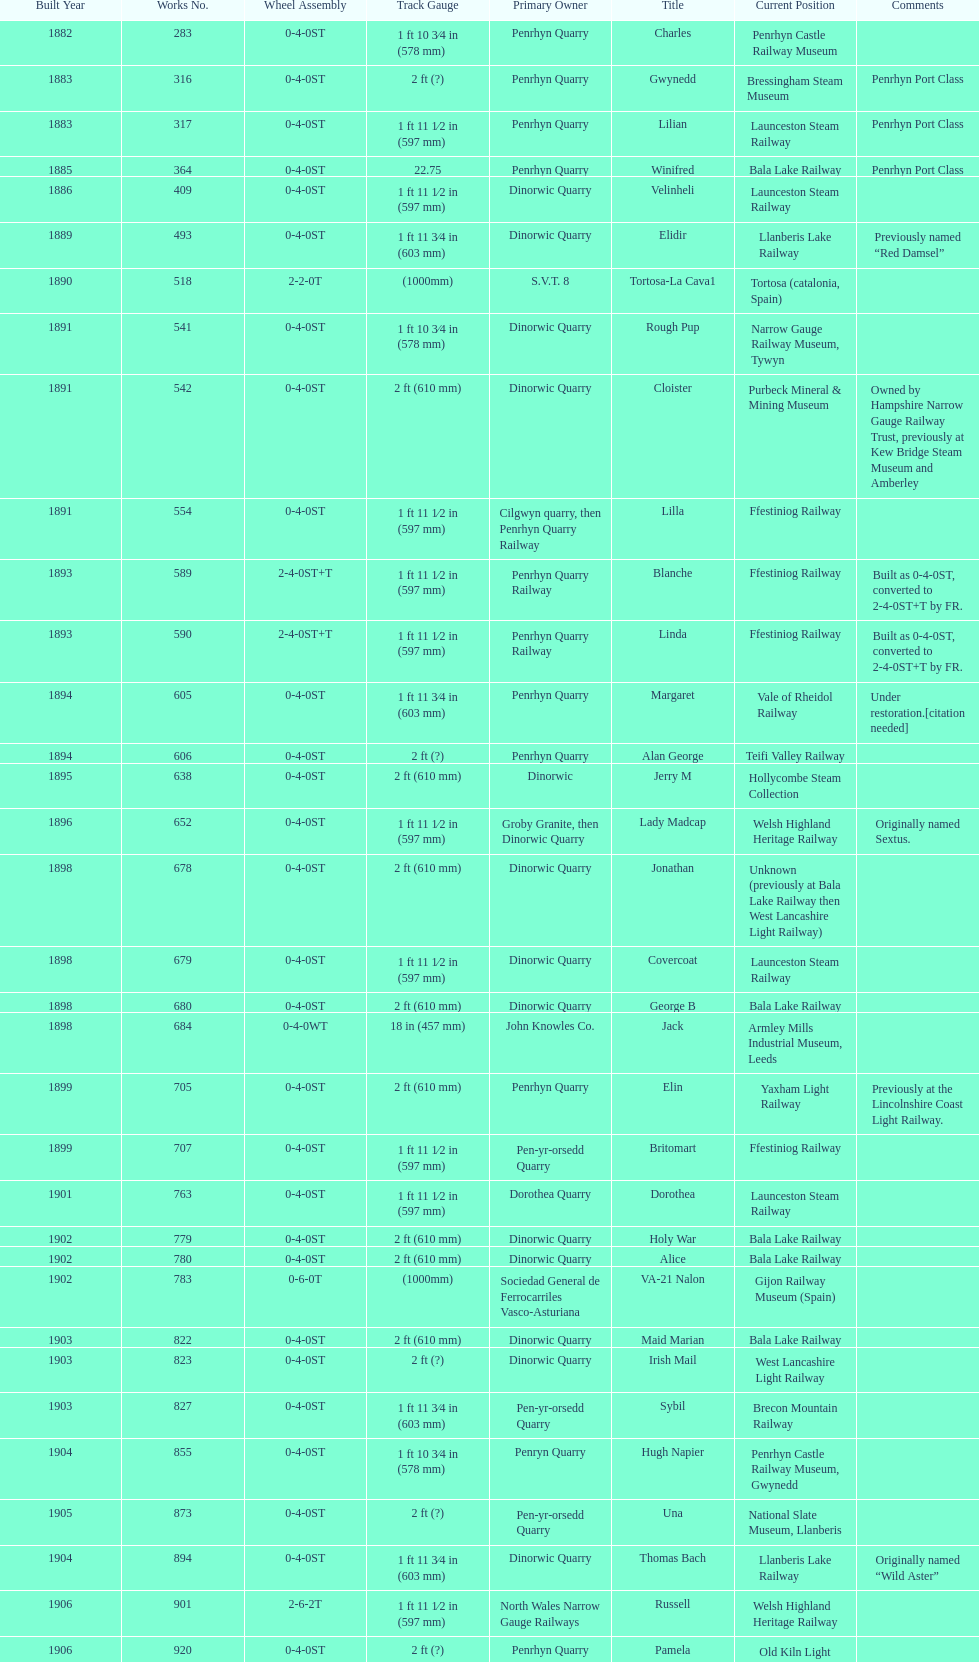Aside from 316, what was the other works number used in 1883? 317. 